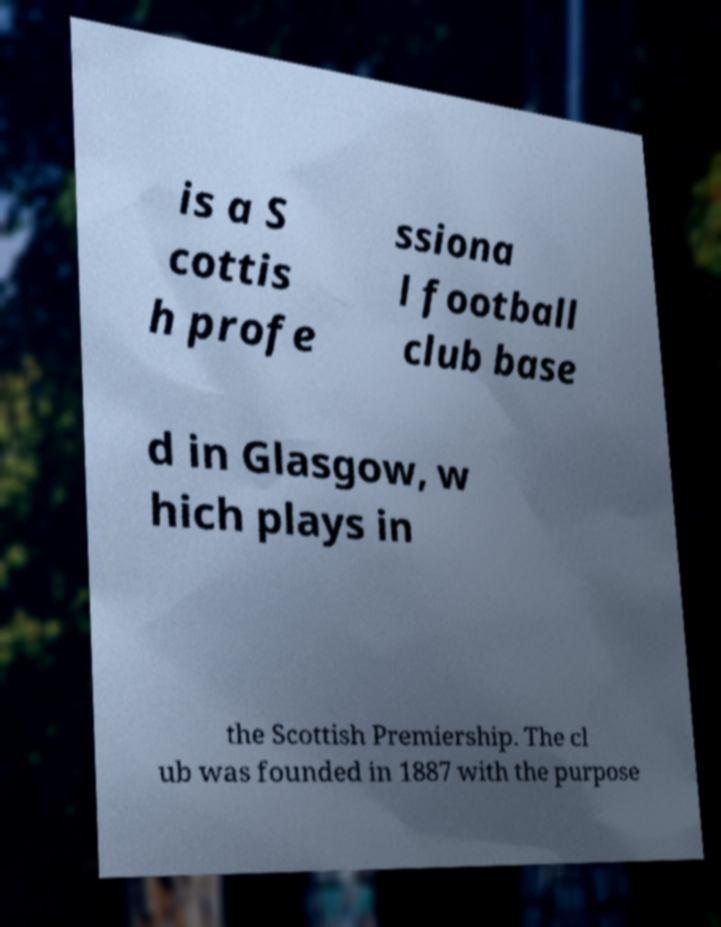Could you extract and type out the text from this image? is a S cottis h profe ssiona l football club base d in Glasgow, w hich plays in the Scottish Premiership. The cl ub was founded in 1887 with the purpose 